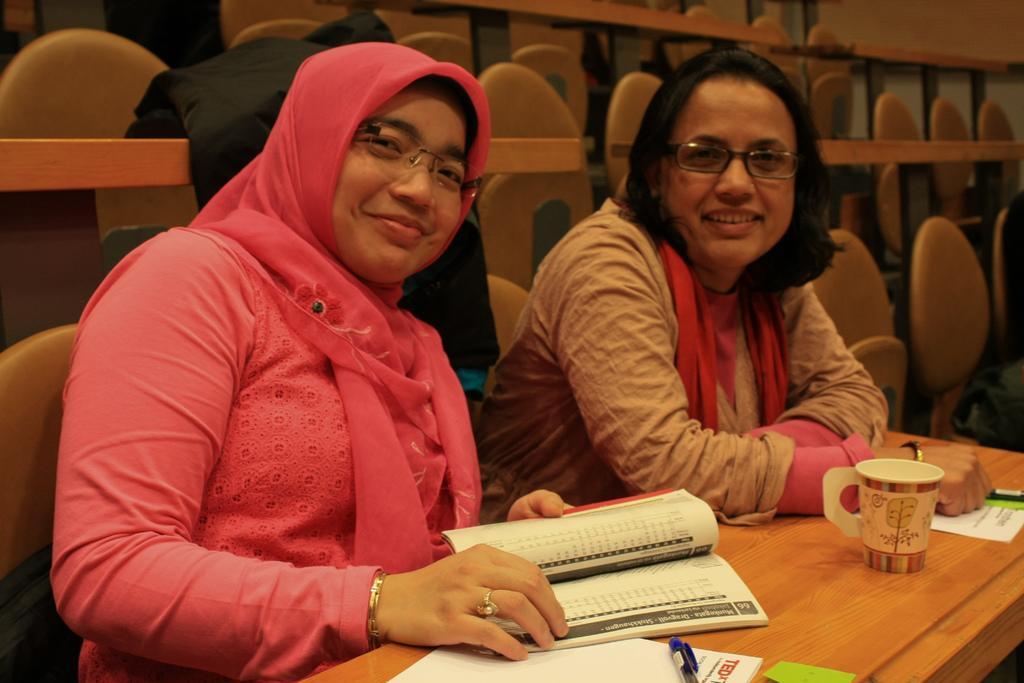Could you give a brief overview of what you see in this image? In this image I see 2 women who are sitting on chairs and I see a table in front of them, on which there is a cup, 2 books and a pen. In the background I see the cloth and chairs. 